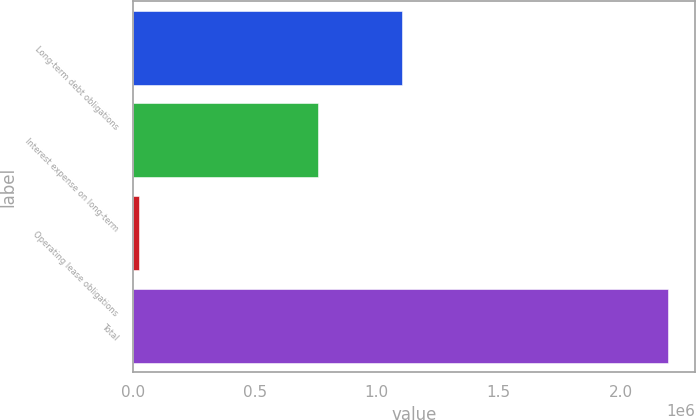<chart> <loc_0><loc_0><loc_500><loc_500><bar_chart><fcel>Long-term debt obligations<fcel>Interest expense on long-term<fcel>Operating lease obligations<fcel>Total<nl><fcel>1.1045e+06<fcel>759850<fcel>25482<fcel>2.19488e+06<nl></chart> 